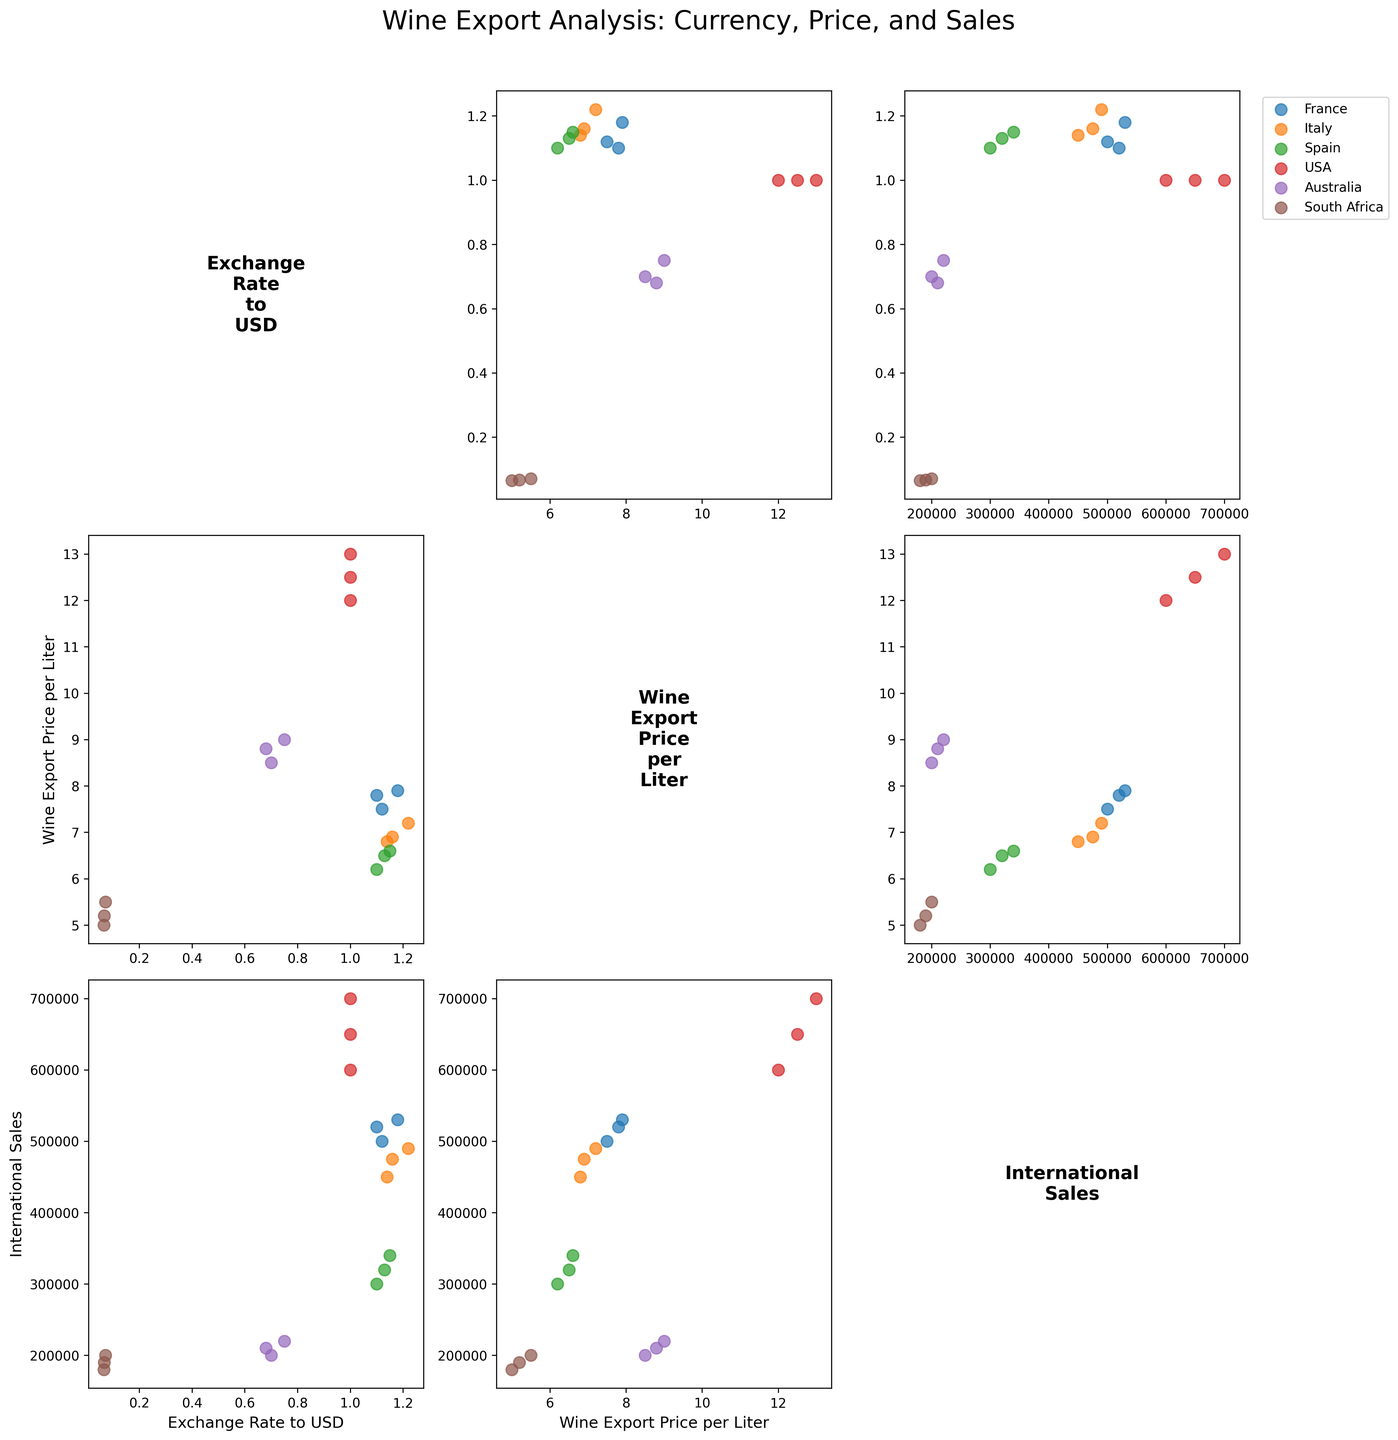What countries are represented in the scatter plot matrix? The scatter plot matrix legend shows different markers for each country. You can identify the countries by looking at the legend positioned in the top right corner of the figure.
Answer: France, Italy, Spain, USA, Australia, South Africa What is the title of the scatter plot matrix? The title is located at the top of the figure. It summarizes the main contents being displayed.
Answer: Wine Export Analysis: Currency, Price, and Sales Which country has the highest wine export price per liter in 2021? To find this, locate the scatter points for the year 2021 in the plot showing "Wine Export Price per Liter" on the y-axis. Compare the values for each country.
Answer: USA How does the exchange rate to USD correlate with international sales for France? Locate the scatter plot where "Exchange Rate to USD" is on the x-axis and "International Sales" is on the y-axis. Observe the trend of the data points, specifically for France.
Answer: Positive correlation, higher exchange rate generally correlates with higher international sales Between 2019 and 2021, which country experienced the largest increase in international sales? Compare the "International Sales" data points for each country between 2019 and 2021. Note the changes and identify the largest increase.
Answer: USA Is there a country that has a constant exchange rate to USD over the years? Review the scatter plots for "Exchange Rate to USD" on the y-axis across the years for each country. One of the countries should show constant values.
Answer: USA Based on the scatter plot matrix, which country appears to have the most consistent wine export prices over the three years? Look at the scatter plots with "Wine Export Price per Liter" on the y-axis. Observe the consistency or variability of the prices for each country over the years.
Answer: USA What relationship can be observed between wine export price per liter and international sales for Australia? Find the plot with "Wine Export Price per Liter" on the x-axis and "International Sales" on the y-axis. Examine the trend of Australia's data points to deduce any relationship.
Answer: Positive correlation, higher prices tend to correlate with increased sales Which country shows the smallest change in the exchange rate to USD between 2019 and 2021? Look at the "Exchange Rate to USD" data points for all countries from 2019 to 2021. Determine which country has the smallest fluctuation.
Answer: South Africa 